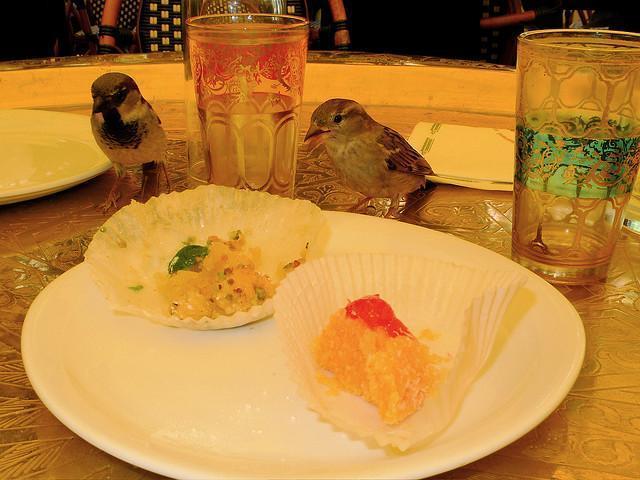Evaluate: Does the caption "The person is in front of the dining table." match the image?
Answer yes or no. No. 